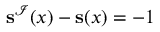Convert formula to latex. <formula><loc_0><loc_0><loc_500><loc_500>s ^ { \mathcal { I } } ( x ) - s ( x ) = - 1</formula> 